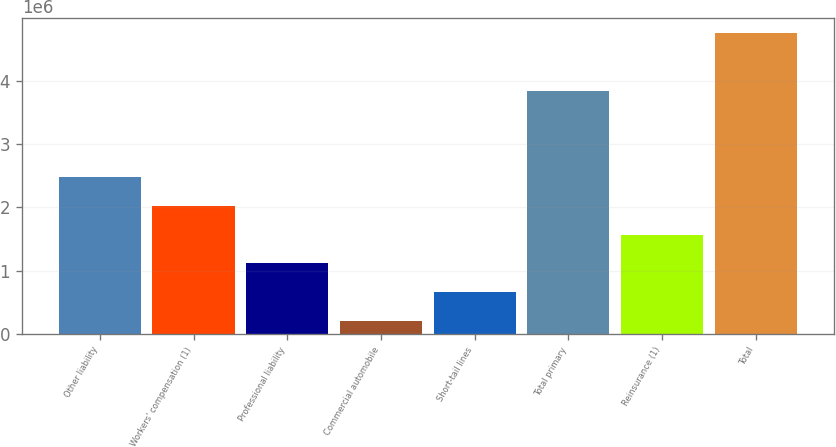<chart> <loc_0><loc_0><loc_500><loc_500><bar_chart><fcel>Other liability<fcel>Workers' compensation (1)<fcel>Professional liability<fcel>Commercial automobile<fcel>Short-tail lines<fcel>Total primary<fcel>Reinsurance (1)<fcel>Total<nl><fcel>2.48167e+06<fcel>2.02642e+06<fcel>1.11591e+06<fcel>205404<fcel>660657<fcel>3.83936e+06<fcel>1.57116e+06<fcel>4.75793e+06<nl></chart> 